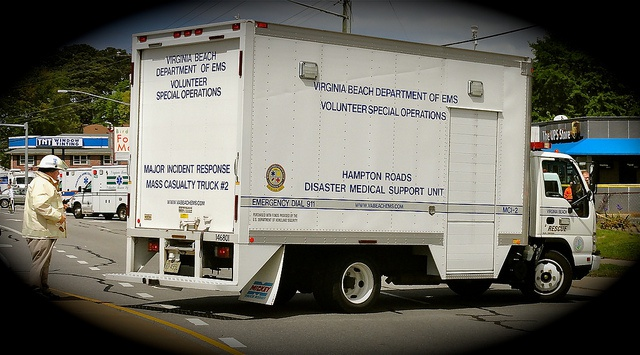Describe the objects in this image and their specific colors. I can see truck in black, lightgray, darkgray, and gray tones, people in black, ivory, and tan tones, truck in black, lightgray, darkgray, and gray tones, car in black, gray, darkgray, and lightgray tones, and people in black, brown, tan, and maroon tones in this image. 